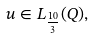Convert formula to latex. <formula><loc_0><loc_0><loc_500><loc_500>u \in L _ { \frac { 1 0 } 3 } ( Q ) ,</formula> 